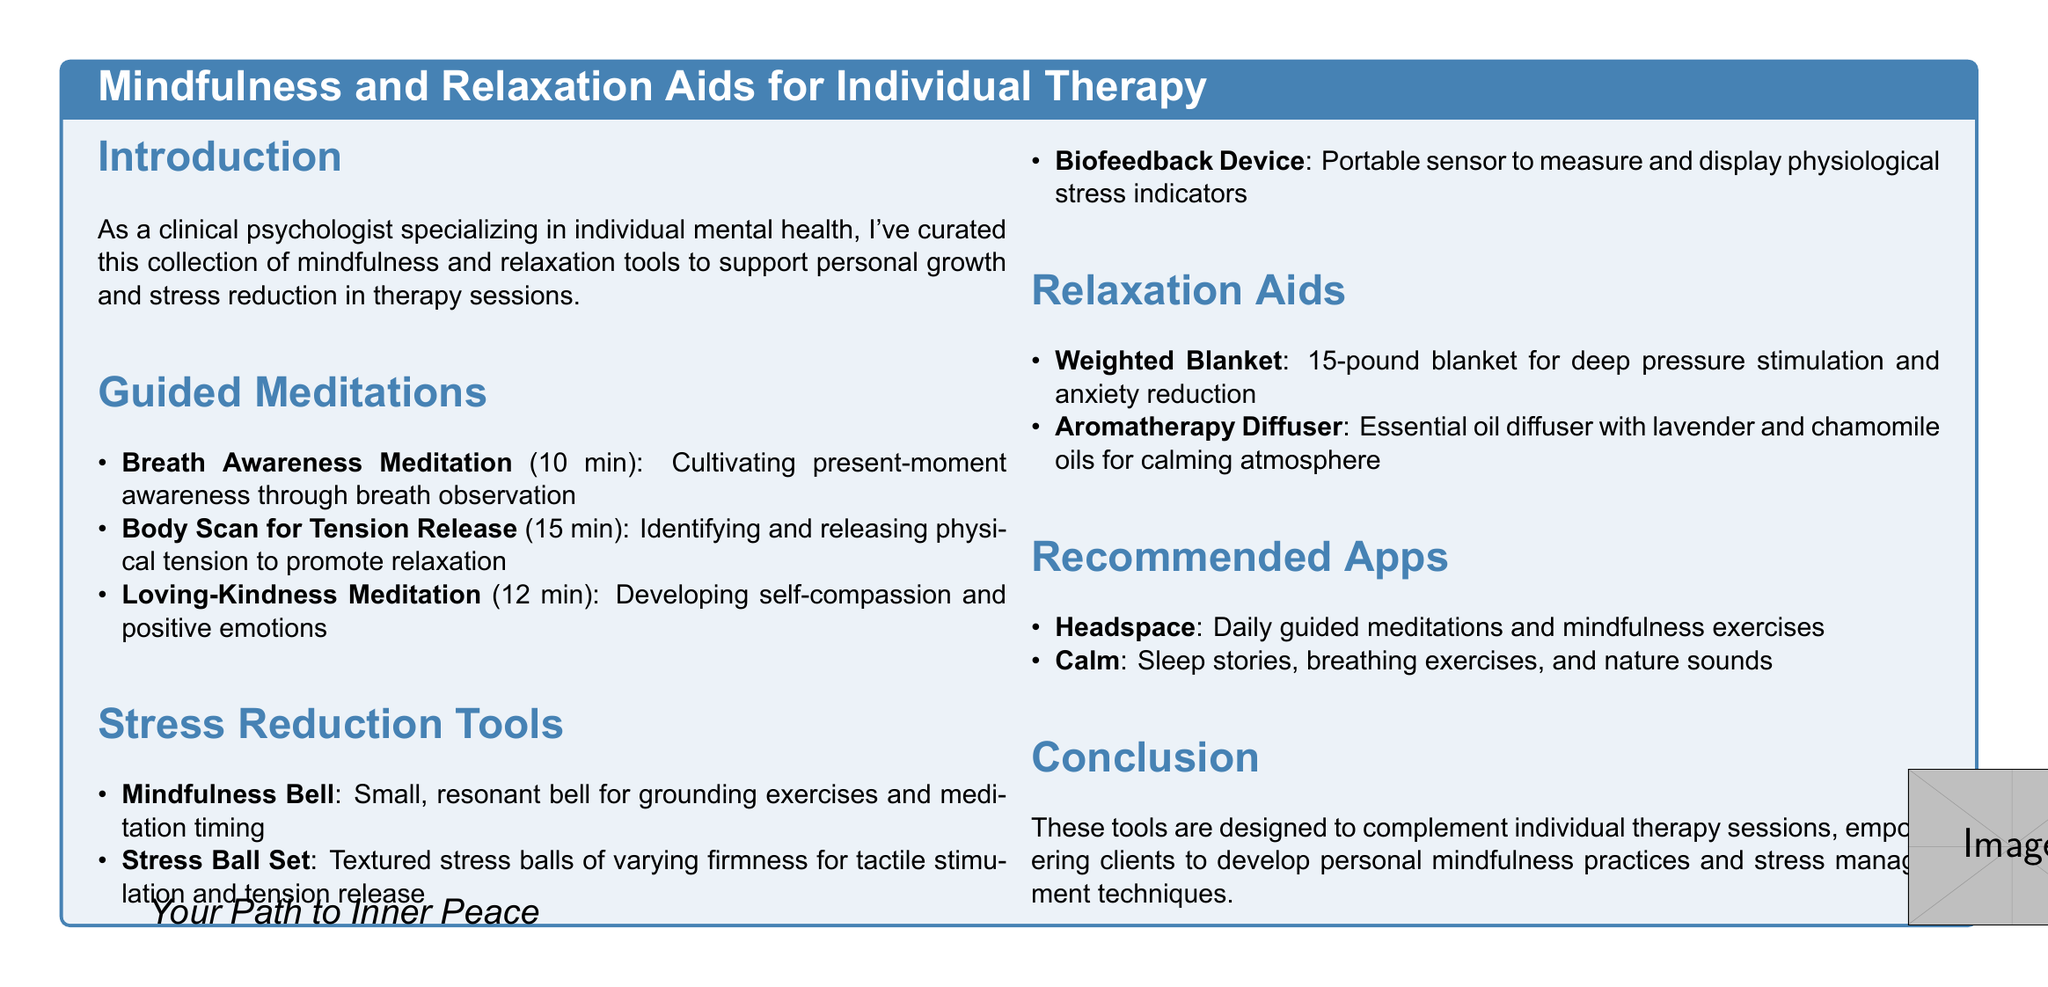What is the total duration of the "Body Scan for Tension Release" meditation? The duration is stated in the document, specifically for that meditation section.
Answer: 15 min How many guided meditations are listed? The number of guided meditation entries can be counted in the guided meditations section of the document.
Answer: 3 What does the Mindfulness Bell aid assist with? The document describes its purpose in relation to mindfulness practices.
Answer: Grounding exercises What weighted blanket weight is recommended? The specific weight is mentioned in the relaxation aids section of the document.
Answer: 15-pound Which app offers sleep stories? The document specifies features of the recommended apps, one of which includes sleep stories.
Answer: Calm What type of oil is mentioned for use with the Aromatherapy Diffuser? The specific type of oil is highlighted within the relaxation aids section of the document.
Answer: Lavender What is the primary goal of the tools listed in the catalog? The conclusion section states the main intention behind the resources provided in the document.
Answer: Empower clients How long does the Loving-Kindness Meditation last? The duration for this particular meditation is provided in the guided meditations section.
Answer: 12 min 